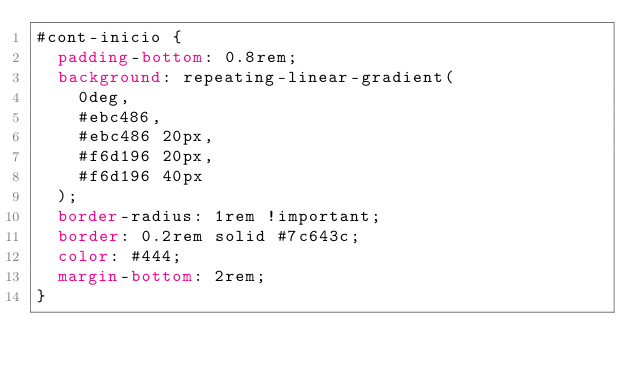<code> <loc_0><loc_0><loc_500><loc_500><_CSS_>#cont-inicio {
	padding-bottom: 0.8rem;
	background: repeating-linear-gradient(
		0deg,
		#ebc486,
		#ebc486 20px,
		#f6d196 20px,
		#f6d196 40px
	);
	border-radius: 1rem !important;
	border: 0.2rem solid #7c643c;
	color: #444;
	margin-bottom: 2rem;
}
</code> 